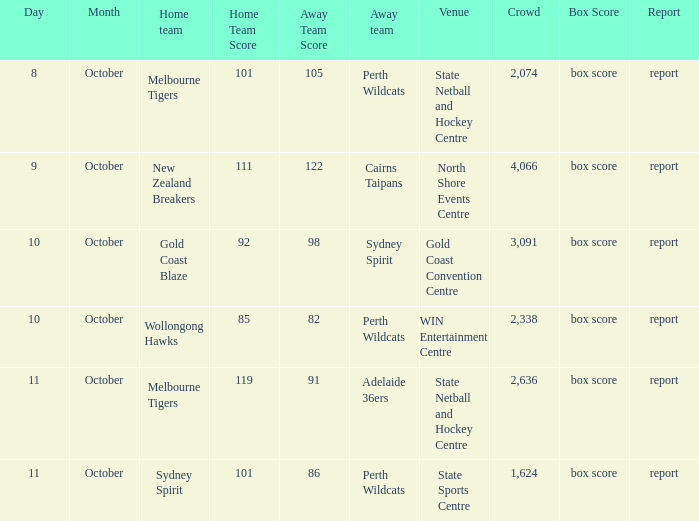What was the crowd size for the game with a score of 101-105? 2074.0. 